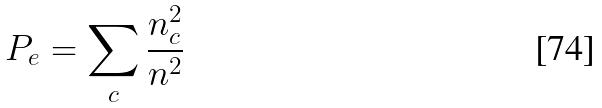<formula> <loc_0><loc_0><loc_500><loc_500>P _ { e } = \sum _ { c } \frac { n _ { c } ^ { 2 } } { n ^ { 2 } }</formula> 